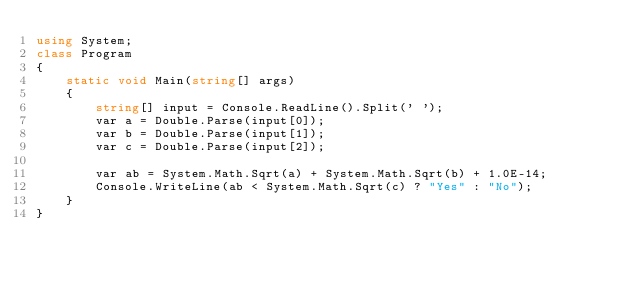<code> <loc_0><loc_0><loc_500><loc_500><_C#_>using System;
class Program
{
	static void Main(string[] args)
	{
		string[] input = Console.ReadLine().Split(' ');
		var a = Double.Parse(input[0]);
		var b = Double.Parse(input[1]);
      	var c = Double.Parse(input[2]);
 
      	var ab = System.Math.Sqrt(a) + System.Math.Sqrt(b) + 1.0E-14;
		Console.WriteLine(ab < System.Math.Sqrt(c) ? "Yes" : "No");
	}
}</code> 